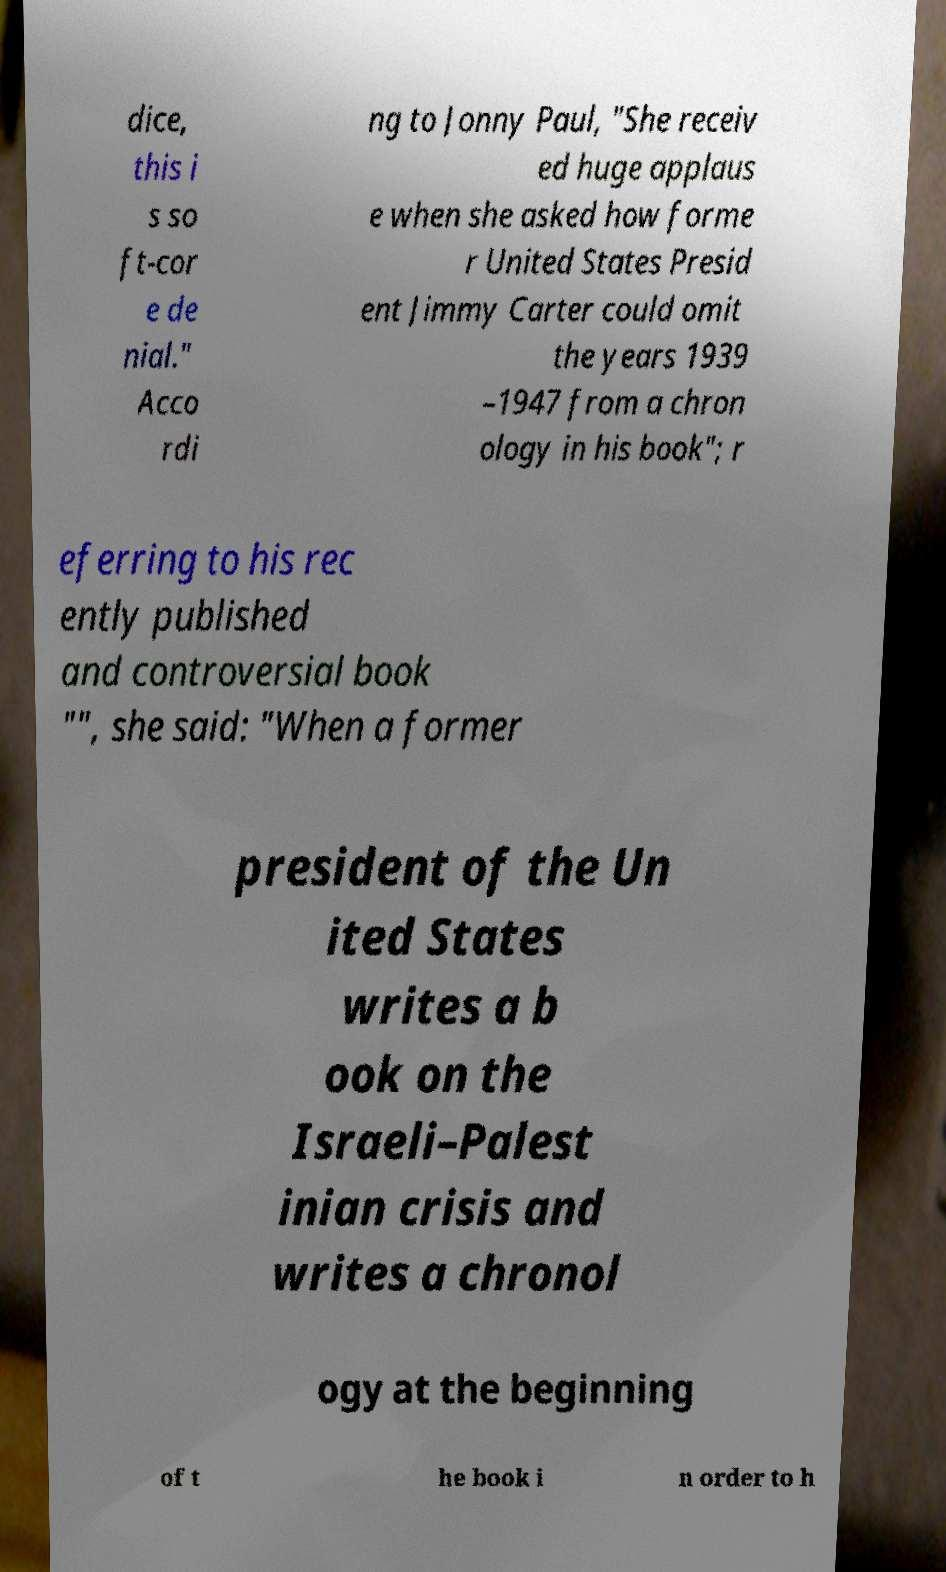For documentation purposes, I need the text within this image transcribed. Could you provide that? dice, this i s so ft-cor e de nial." Acco rdi ng to Jonny Paul, "She receiv ed huge applaus e when she asked how forme r United States Presid ent Jimmy Carter could omit the years 1939 –1947 from a chron ology in his book"; r eferring to his rec ently published and controversial book "", she said: "When a former president of the Un ited States writes a b ook on the Israeli–Palest inian crisis and writes a chronol ogy at the beginning of t he book i n order to h 